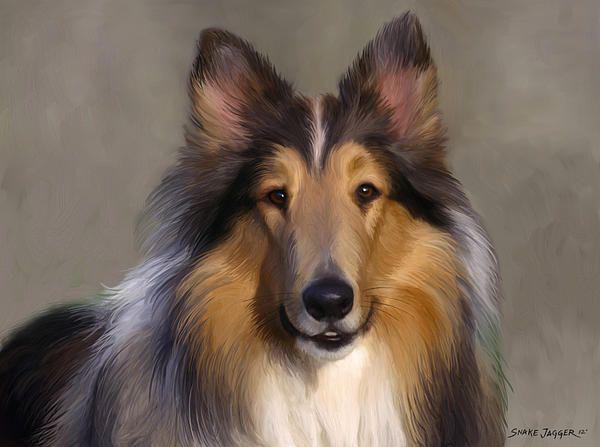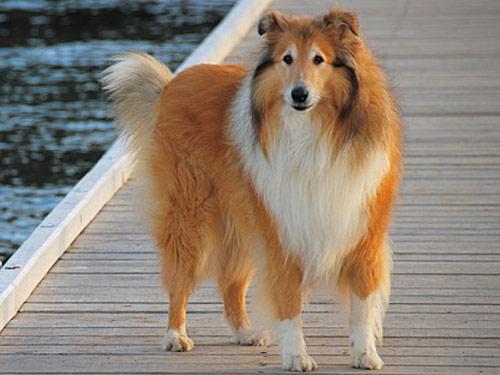The first image is the image on the left, the second image is the image on the right. Examine the images to the left and right. Is the description "The left image features a collie on a mottled, non-white portrait background." accurate? Answer yes or no. Yes. 